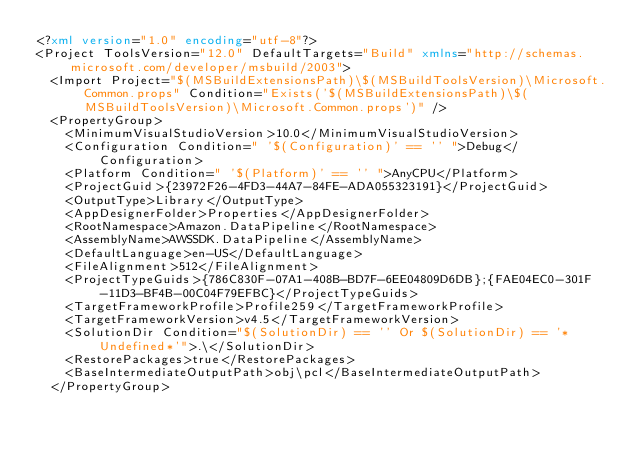Convert code to text. <code><loc_0><loc_0><loc_500><loc_500><_XML_><?xml version="1.0" encoding="utf-8"?>
<Project ToolsVersion="12.0" DefaultTargets="Build" xmlns="http://schemas.microsoft.com/developer/msbuild/2003">
  <Import Project="$(MSBuildExtensionsPath)\$(MSBuildToolsVersion)\Microsoft.Common.props" Condition="Exists('$(MSBuildExtensionsPath)\$(MSBuildToolsVersion)\Microsoft.Common.props')" />
  <PropertyGroup>
    <MinimumVisualStudioVersion>10.0</MinimumVisualStudioVersion>
    <Configuration Condition=" '$(Configuration)' == '' ">Debug</Configuration>
    <Platform Condition=" '$(Platform)' == '' ">AnyCPU</Platform>
    <ProjectGuid>{23972F26-4FD3-44A7-84FE-ADA055323191}</ProjectGuid>
    <OutputType>Library</OutputType>
    <AppDesignerFolder>Properties</AppDesignerFolder>
    <RootNamespace>Amazon.DataPipeline</RootNamespace>
    <AssemblyName>AWSSDK.DataPipeline</AssemblyName>
    <DefaultLanguage>en-US</DefaultLanguage>
    <FileAlignment>512</FileAlignment>
    <ProjectTypeGuids>{786C830F-07A1-408B-BD7F-6EE04809D6DB};{FAE04EC0-301F-11D3-BF4B-00C04F79EFBC}</ProjectTypeGuids>
    <TargetFrameworkProfile>Profile259</TargetFrameworkProfile>
    <TargetFrameworkVersion>v4.5</TargetFrameworkVersion>
    <SolutionDir Condition="$(SolutionDir) == '' Or $(SolutionDir) == '*Undefined*'">.\</SolutionDir>
    <RestorePackages>true</RestorePackages>
    <BaseIntermediateOutputPath>obj\pcl</BaseIntermediateOutputPath>
  </PropertyGroup></code> 